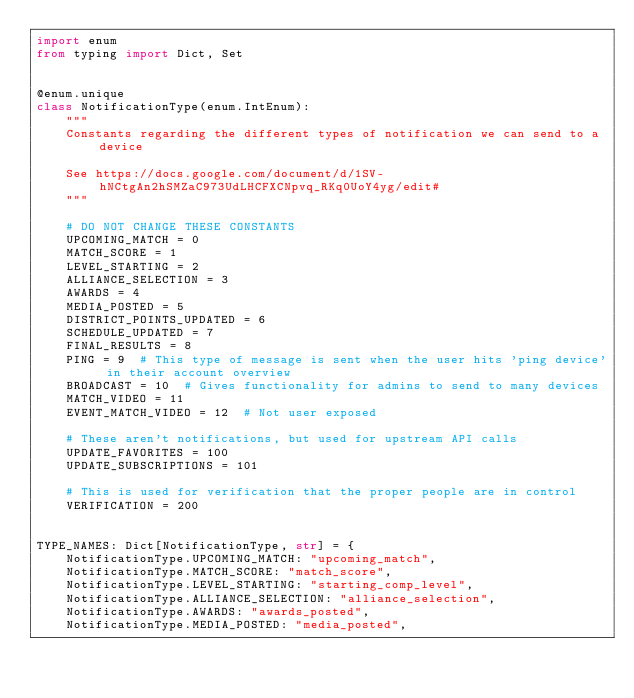<code> <loc_0><loc_0><loc_500><loc_500><_Python_>import enum
from typing import Dict, Set


@enum.unique
class NotificationType(enum.IntEnum):
    """
    Constants regarding the different types of notification we can send to a device

    See https://docs.google.com/document/d/1SV-hNCtgAn2hSMZaC973UdLHCFXCNpvq_RKq0UoY4yg/edit#
    """

    # DO NOT CHANGE THESE CONSTANTS
    UPCOMING_MATCH = 0
    MATCH_SCORE = 1
    LEVEL_STARTING = 2
    ALLIANCE_SELECTION = 3
    AWARDS = 4
    MEDIA_POSTED = 5
    DISTRICT_POINTS_UPDATED = 6
    SCHEDULE_UPDATED = 7
    FINAL_RESULTS = 8
    PING = 9  # This type of message is sent when the user hits 'ping device' in their account overview
    BROADCAST = 10  # Gives functionality for admins to send to many devices
    MATCH_VIDEO = 11
    EVENT_MATCH_VIDEO = 12  # Not user exposed

    # These aren't notifications, but used for upstream API calls
    UPDATE_FAVORITES = 100
    UPDATE_SUBSCRIPTIONS = 101

    # This is used for verification that the proper people are in control
    VERIFICATION = 200


TYPE_NAMES: Dict[NotificationType, str] = {
    NotificationType.UPCOMING_MATCH: "upcoming_match",
    NotificationType.MATCH_SCORE: "match_score",
    NotificationType.LEVEL_STARTING: "starting_comp_level",
    NotificationType.ALLIANCE_SELECTION: "alliance_selection",
    NotificationType.AWARDS: "awards_posted",
    NotificationType.MEDIA_POSTED: "media_posted",</code> 